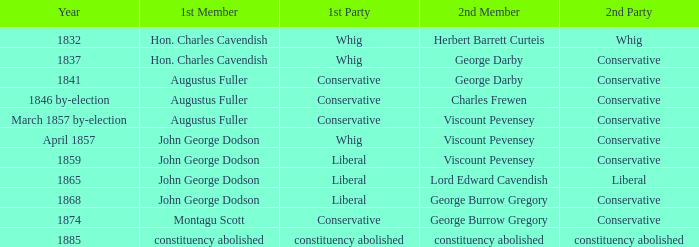In 1865, what was the foremost party? Liberal. 